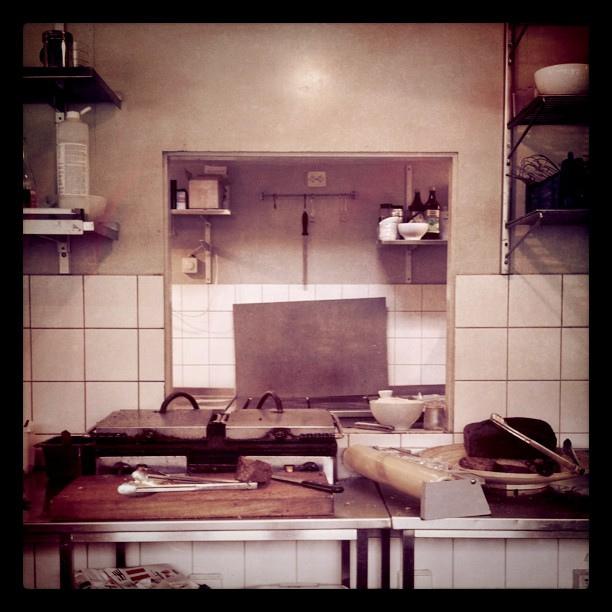Where is the mirror located?
Give a very brief answer. Wall. Is this an old picture?
Concise answer only. Yes. Is there white tile on the wall?
Write a very short answer. Yes. 